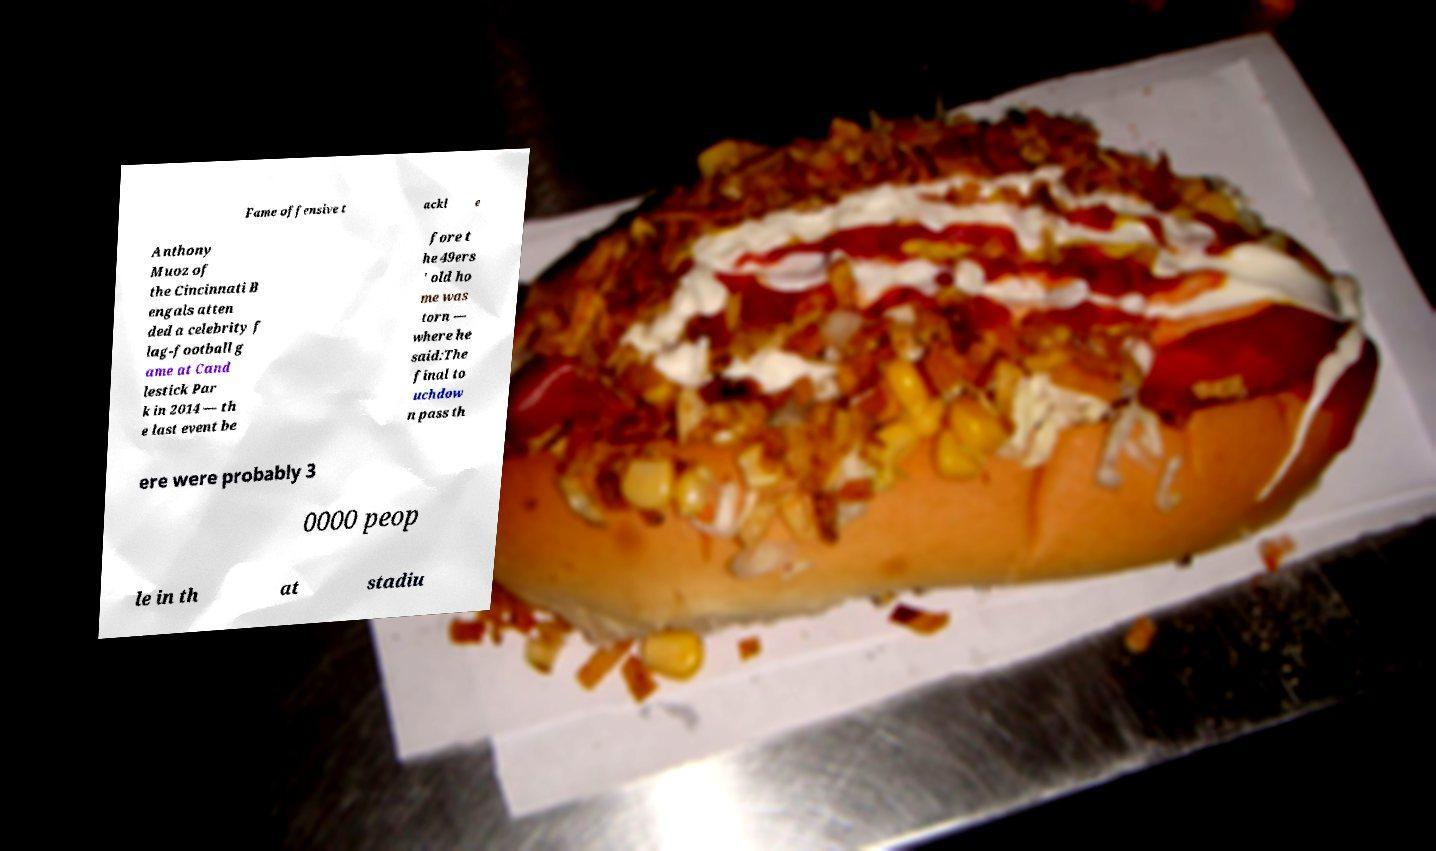Could you extract and type out the text from this image? Fame offensive t ackl e Anthony Muoz of the Cincinnati B engals atten ded a celebrity f lag-football g ame at Cand lestick Par k in 2014 — th e last event be fore t he 49ers ' old ho me was torn — where he said:The final to uchdow n pass th ere were probably 3 0000 peop le in th at stadiu 